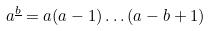<formula> <loc_0><loc_0><loc_500><loc_500>a ^ { \underline { b } } = a ( a - 1 ) \dots ( a - b + 1 )</formula> 